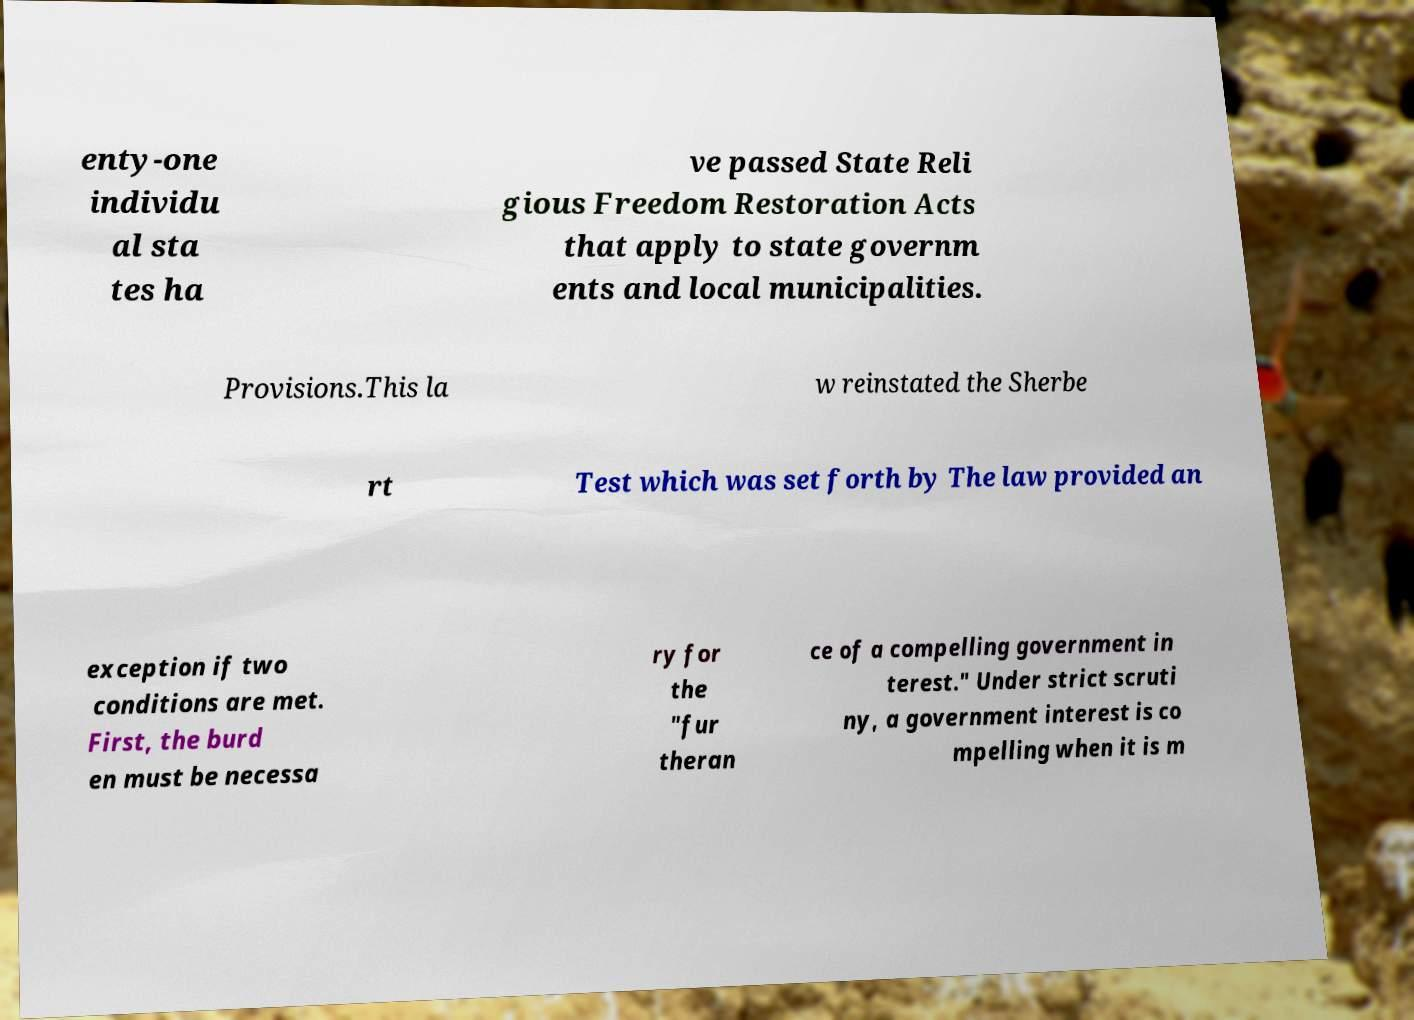What messages or text are displayed in this image? I need them in a readable, typed format. enty-one individu al sta tes ha ve passed State Reli gious Freedom Restoration Acts that apply to state governm ents and local municipalities. Provisions.This la w reinstated the Sherbe rt Test which was set forth by The law provided an exception if two conditions are met. First, the burd en must be necessa ry for the "fur theran ce of a compelling government in terest." Under strict scruti ny, a government interest is co mpelling when it is m 